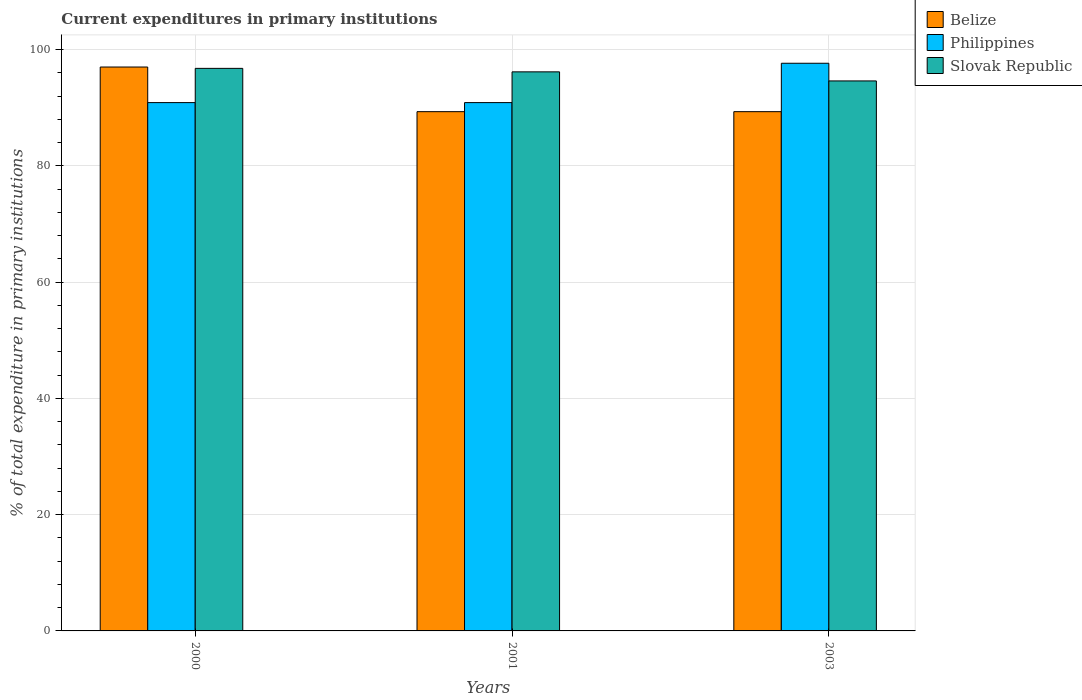How many groups of bars are there?
Keep it short and to the point. 3. Are the number of bars on each tick of the X-axis equal?
Offer a very short reply. Yes. How many bars are there on the 3rd tick from the right?
Ensure brevity in your answer.  3. In how many cases, is the number of bars for a given year not equal to the number of legend labels?
Offer a very short reply. 0. What is the current expenditures in primary institutions in Slovak Republic in 2003?
Keep it short and to the point. 94.61. Across all years, what is the maximum current expenditures in primary institutions in Slovak Republic?
Give a very brief answer. 96.77. Across all years, what is the minimum current expenditures in primary institutions in Slovak Republic?
Provide a short and direct response. 94.61. What is the total current expenditures in primary institutions in Slovak Republic in the graph?
Your answer should be very brief. 287.56. What is the difference between the current expenditures in primary institutions in Slovak Republic in 2001 and that in 2003?
Give a very brief answer. 1.56. What is the difference between the current expenditures in primary institutions in Philippines in 2003 and the current expenditures in primary institutions in Belize in 2001?
Offer a terse response. 8.33. What is the average current expenditures in primary institutions in Philippines per year?
Your response must be concise. 93.14. In the year 2001, what is the difference between the current expenditures in primary institutions in Slovak Republic and current expenditures in primary institutions in Belize?
Ensure brevity in your answer.  6.85. In how many years, is the current expenditures in primary institutions in Philippines greater than 12 %?
Keep it short and to the point. 3. What is the ratio of the current expenditures in primary institutions in Belize in 2000 to that in 2001?
Offer a terse response. 1.09. Is the current expenditures in primary institutions in Belize in 2000 less than that in 2003?
Provide a succinct answer. No. What is the difference between the highest and the second highest current expenditures in primary institutions in Philippines?
Your response must be concise. 6.77. What is the difference between the highest and the lowest current expenditures in primary institutions in Belize?
Your response must be concise. 7.68. In how many years, is the current expenditures in primary institutions in Belize greater than the average current expenditures in primary institutions in Belize taken over all years?
Your answer should be very brief. 1. Is the sum of the current expenditures in primary institutions in Slovak Republic in 2000 and 2001 greater than the maximum current expenditures in primary institutions in Belize across all years?
Offer a terse response. Yes. What does the 2nd bar from the left in 2001 represents?
Offer a terse response. Philippines. What does the 1st bar from the right in 2000 represents?
Provide a short and direct response. Slovak Republic. Are all the bars in the graph horizontal?
Your answer should be very brief. No. How many years are there in the graph?
Give a very brief answer. 3. Are the values on the major ticks of Y-axis written in scientific E-notation?
Offer a very short reply. No. Does the graph contain any zero values?
Make the answer very short. No. Does the graph contain grids?
Your answer should be compact. Yes. How many legend labels are there?
Ensure brevity in your answer.  3. How are the legend labels stacked?
Give a very brief answer. Vertical. What is the title of the graph?
Your answer should be compact. Current expenditures in primary institutions. Does "Uzbekistan" appear as one of the legend labels in the graph?
Keep it short and to the point. No. What is the label or title of the X-axis?
Your response must be concise. Years. What is the label or title of the Y-axis?
Make the answer very short. % of total expenditure in primary institutions. What is the % of total expenditure in primary institutions of Belize in 2000?
Your response must be concise. 97. What is the % of total expenditure in primary institutions in Philippines in 2000?
Offer a terse response. 90.88. What is the % of total expenditure in primary institutions in Slovak Republic in 2000?
Offer a terse response. 96.77. What is the % of total expenditure in primary institutions in Belize in 2001?
Ensure brevity in your answer.  89.32. What is the % of total expenditure in primary institutions in Philippines in 2001?
Offer a very short reply. 90.88. What is the % of total expenditure in primary institutions of Slovak Republic in 2001?
Offer a very short reply. 96.17. What is the % of total expenditure in primary institutions of Belize in 2003?
Your answer should be very brief. 89.32. What is the % of total expenditure in primary institutions of Philippines in 2003?
Your response must be concise. 97.65. What is the % of total expenditure in primary institutions of Slovak Republic in 2003?
Your response must be concise. 94.61. Across all years, what is the maximum % of total expenditure in primary institutions in Belize?
Provide a succinct answer. 97. Across all years, what is the maximum % of total expenditure in primary institutions of Philippines?
Offer a very short reply. 97.65. Across all years, what is the maximum % of total expenditure in primary institutions in Slovak Republic?
Offer a terse response. 96.77. Across all years, what is the minimum % of total expenditure in primary institutions of Belize?
Provide a short and direct response. 89.32. Across all years, what is the minimum % of total expenditure in primary institutions of Philippines?
Provide a short and direct response. 90.88. Across all years, what is the minimum % of total expenditure in primary institutions of Slovak Republic?
Your response must be concise. 94.61. What is the total % of total expenditure in primary institutions in Belize in the graph?
Ensure brevity in your answer.  275.65. What is the total % of total expenditure in primary institutions of Philippines in the graph?
Your answer should be very brief. 279.42. What is the total % of total expenditure in primary institutions in Slovak Republic in the graph?
Offer a very short reply. 287.56. What is the difference between the % of total expenditure in primary institutions in Belize in 2000 and that in 2001?
Provide a short and direct response. 7.68. What is the difference between the % of total expenditure in primary institutions of Slovak Republic in 2000 and that in 2001?
Your answer should be very brief. 0.6. What is the difference between the % of total expenditure in primary institutions in Belize in 2000 and that in 2003?
Your response must be concise. 7.68. What is the difference between the % of total expenditure in primary institutions in Philippines in 2000 and that in 2003?
Offer a very short reply. -6.77. What is the difference between the % of total expenditure in primary institutions of Slovak Republic in 2000 and that in 2003?
Keep it short and to the point. 2.16. What is the difference between the % of total expenditure in primary institutions in Belize in 2001 and that in 2003?
Your answer should be very brief. 0. What is the difference between the % of total expenditure in primary institutions of Philippines in 2001 and that in 2003?
Ensure brevity in your answer.  -6.77. What is the difference between the % of total expenditure in primary institutions in Slovak Republic in 2001 and that in 2003?
Your response must be concise. 1.56. What is the difference between the % of total expenditure in primary institutions of Belize in 2000 and the % of total expenditure in primary institutions of Philippines in 2001?
Your answer should be compact. 6.12. What is the difference between the % of total expenditure in primary institutions in Belize in 2000 and the % of total expenditure in primary institutions in Slovak Republic in 2001?
Provide a succinct answer. 0.83. What is the difference between the % of total expenditure in primary institutions in Philippines in 2000 and the % of total expenditure in primary institutions in Slovak Republic in 2001?
Provide a short and direct response. -5.29. What is the difference between the % of total expenditure in primary institutions of Belize in 2000 and the % of total expenditure in primary institutions of Philippines in 2003?
Give a very brief answer. -0.65. What is the difference between the % of total expenditure in primary institutions in Belize in 2000 and the % of total expenditure in primary institutions in Slovak Republic in 2003?
Give a very brief answer. 2.39. What is the difference between the % of total expenditure in primary institutions in Philippines in 2000 and the % of total expenditure in primary institutions in Slovak Republic in 2003?
Keep it short and to the point. -3.73. What is the difference between the % of total expenditure in primary institutions of Belize in 2001 and the % of total expenditure in primary institutions of Philippines in 2003?
Give a very brief answer. -8.33. What is the difference between the % of total expenditure in primary institutions of Belize in 2001 and the % of total expenditure in primary institutions of Slovak Republic in 2003?
Provide a short and direct response. -5.29. What is the difference between the % of total expenditure in primary institutions in Philippines in 2001 and the % of total expenditure in primary institutions in Slovak Republic in 2003?
Give a very brief answer. -3.73. What is the average % of total expenditure in primary institutions of Belize per year?
Keep it short and to the point. 91.88. What is the average % of total expenditure in primary institutions in Philippines per year?
Your response must be concise. 93.14. What is the average % of total expenditure in primary institutions in Slovak Republic per year?
Keep it short and to the point. 95.85. In the year 2000, what is the difference between the % of total expenditure in primary institutions of Belize and % of total expenditure in primary institutions of Philippines?
Ensure brevity in your answer.  6.12. In the year 2000, what is the difference between the % of total expenditure in primary institutions in Belize and % of total expenditure in primary institutions in Slovak Republic?
Keep it short and to the point. 0.23. In the year 2000, what is the difference between the % of total expenditure in primary institutions in Philippines and % of total expenditure in primary institutions in Slovak Republic?
Your answer should be compact. -5.89. In the year 2001, what is the difference between the % of total expenditure in primary institutions of Belize and % of total expenditure in primary institutions of Philippines?
Your answer should be compact. -1.56. In the year 2001, what is the difference between the % of total expenditure in primary institutions of Belize and % of total expenditure in primary institutions of Slovak Republic?
Give a very brief answer. -6.85. In the year 2001, what is the difference between the % of total expenditure in primary institutions in Philippines and % of total expenditure in primary institutions in Slovak Republic?
Make the answer very short. -5.29. In the year 2003, what is the difference between the % of total expenditure in primary institutions in Belize and % of total expenditure in primary institutions in Philippines?
Provide a succinct answer. -8.33. In the year 2003, what is the difference between the % of total expenditure in primary institutions in Belize and % of total expenditure in primary institutions in Slovak Republic?
Ensure brevity in your answer.  -5.29. In the year 2003, what is the difference between the % of total expenditure in primary institutions of Philippines and % of total expenditure in primary institutions of Slovak Republic?
Provide a succinct answer. 3.04. What is the ratio of the % of total expenditure in primary institutions of Belize in 2000 to that in 2001?
Ensure brevity in your answer.  1.09. What is the ratio of the % of total expenditure in primary institutions of Belize in 2000 to that in 2003?
Make the answer very short. 1.09. What is the ratio of the % of total expenditure in primary institutions of Philippines in 2000 to that in 2003?
Your answer should be compact. 0.93. What is the ratio of the % of total expenditure in primary institutions of Slovak Republic in 2000 to that in 2003?
Your response must be concise. 1.02. What is the ratio of the % of total expenditure in primary institutions in Philippines in 2001 to that in 2003?
Make the answer very short. 0.93. What is the ratio of the % of total expenditure in primary institutions in Slovak Republic in 2001 to that in 2003?
Give a very brief answer. 1.02. What is the difference between the highest and the second highest % of total expenditure in primary institutions in Belize?
Your response must be concise. 7.68. What is the difference between the highest and the second highest % of total expenditure in primary institutions in Philippines?
Offer a terse response. 6.77. What is the difference between the highest and the second highest % of total expenditure in primary institutions of Slovak Republic?
Keep it short and to the point. 0.6. What is the difference between the highest and the lowest % of total expenditure in primary institutions of Belize?
Your answer should be compact. 7.68. What is the difference between the highest and the lowest % of total expenditure in primary institutions in Philippines?
Make the answer very short. 6.77. What is the difference between the highest and the lowest % of total expenditure in primary institutions in Slovak Republic?
Provide a succinct answer. 2.16. 